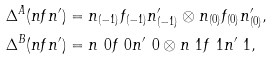<formula> <loc_0><loc_0><loc_500><loc_500>\Delta ^ { A } ( n f n ^ { \prime } ) & = n _ { ( - 1 ) } f _ { ( - 1 ) } n ^ { \prime } _ { ( - 1 ) } \otimes n _ { ( 0 ) } f _ { ( 0 ) } n ^ { \prime } _ { ( 0 ) } , \\ \Delta ^ { B } ( n f n ^ { \prime } ) & = n \ 0 f \ 0 n ^ { \prime } \ 0 \otimes n \ 1 f \ 1 n ^ { \prime } \ 1 ,</formula> 